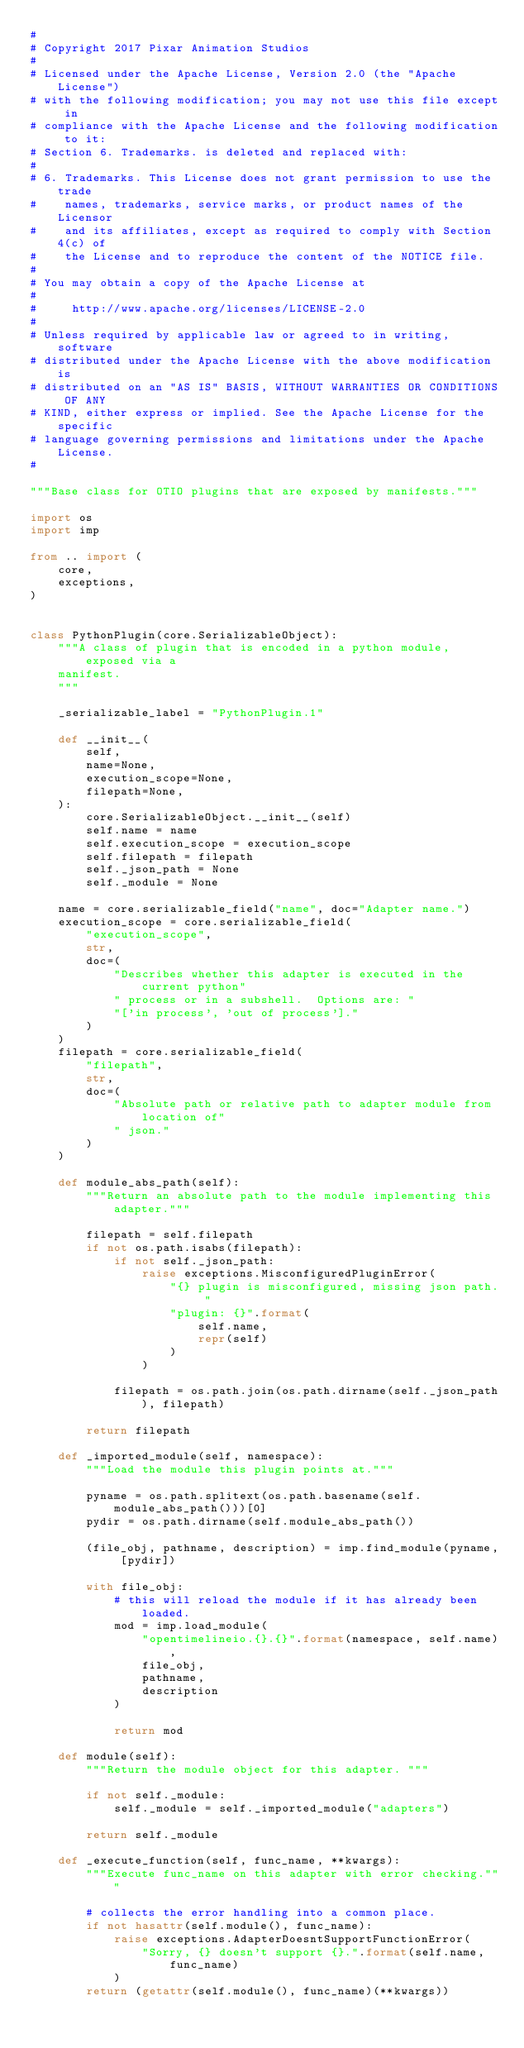Convert code to text. <code><loc_0><loc_0><loc_500><loc_500><_Python_>#
# Copyright 2017 Pixar Animation Studios
#
# Licensed under the Apache License, Version 2.0 (the "Apache License")
# with the following modification; you may not use this file except in
# compliance with the Apache License and the following modification to it:
# Section 6. Trademarks. is deleted and replaced with:
#
# 6. Trademarks. This License does not grant permission to use the trade
#    names, trademarks, service marks, or product names of the Licensor
#    and its affiliates, except as required to comply with Section 4(c) of
#    the License and to reproduce the content of the NOTICE file.
#
# You may obtain a copy of the Apache License at
#
#     http://www.apache.org/licenses/LICENSE-2.0
#
# Unless required by applicable law or agreed to in writing, software
# distributed under the Apache License with the above modification is
# distributed on an "AS IS" BASIS, WITHOUT WARRANTIES OR CONDITIONS OF ANY
# KIND, either express or implied. See the Apache License for the specific
# language governing permissions and limitations under the Apache License.
#

"""Base class for OTIO plugins that are exposed by manifests."""

import os
import imp

from .. import (
    core,
    exceptions,
)


class PythonPlugin(core.SerializableObject):
    """A class of plugin that is encoded in a python module, exposed via a
    manifest.
    """

    _serializable_label = "PythonPlugin.1"

    def __init__(
        self,
        name=None,
        execution_scope=None,
        filepath=None,
    ):
        core.SerializableObject.__init__(self)
        self.name = name
        self.execution_scope = execution_scope
        self.filepath = filepath
        self._json_path = None
        self._module = None

    name = core.serializable_field("name", doc="Adapter name.")
    execution_scope = core.serializable_field(
        "execution_scope",
        str,
        doc=(
            "Describes whether this adapter is executed in the current python"
            " process or in a subshell.  Options are: "
            "['in process', 'out of process']."
        )
    )
    filepath = core.serializable_field(
        "filepath",
        str,
        doc=(
            "Absolute path or relative path to adapter module from location of"
            " json."
        )
    )

    def module_abs_path(self):
        """Return an absolute path to the module implementing this adapter."""

        filepath = self.filepath
        if not os.path.isabs(filepath):
            if not self._json_path:
                raise exceptions.MisconfiguredPluginError(
                    "{} plugin is misconfigured, missing json path. "
                    "plugin: {}".format(
                        self.name,
                        repr(self)
                    )
                )

            filepath = os.path.join(os.path.dirname(self._json_path), filepath)

        return filepath

    def _imported_module(self, namespace):
        """Load the module this plugin points at."""

        pyname = os.path.splitext(os.path.basename(self.module_abs_path()))[0]
        pydir = os.path.dirname(self.module_abs_path())

        (file_obj, pathname, description) = imp.find_module(pyname, [pydir])

        with file_obj:
            # this will reload the module if it has already been loaded.
            mod = imp.load_module(
                "opentimelineio.{}.{}".format(namespace, self.name),
                file_obj,
                pathname,
                description
            )

            return mod

    def module(self):
        """Return the module object for this adapter. """

        if not self._module:
            self._module = self._imported_module("adapters")

        return self._module

    def _execute_function(self, func_name, **kwargs):
        """Execute func_name on this adapter with error checking."""

        # collects the error handling into a common place.
        if not hasattr(self.module(), func_name):
            raise exceptions.AdapterDoesntSupportFunctionError(
                "Sorry, {} doesn't support {}.".format(self.name, func_name)
            )
        return (getattr(self.module(), func_name)(**kwargs))
</code> 